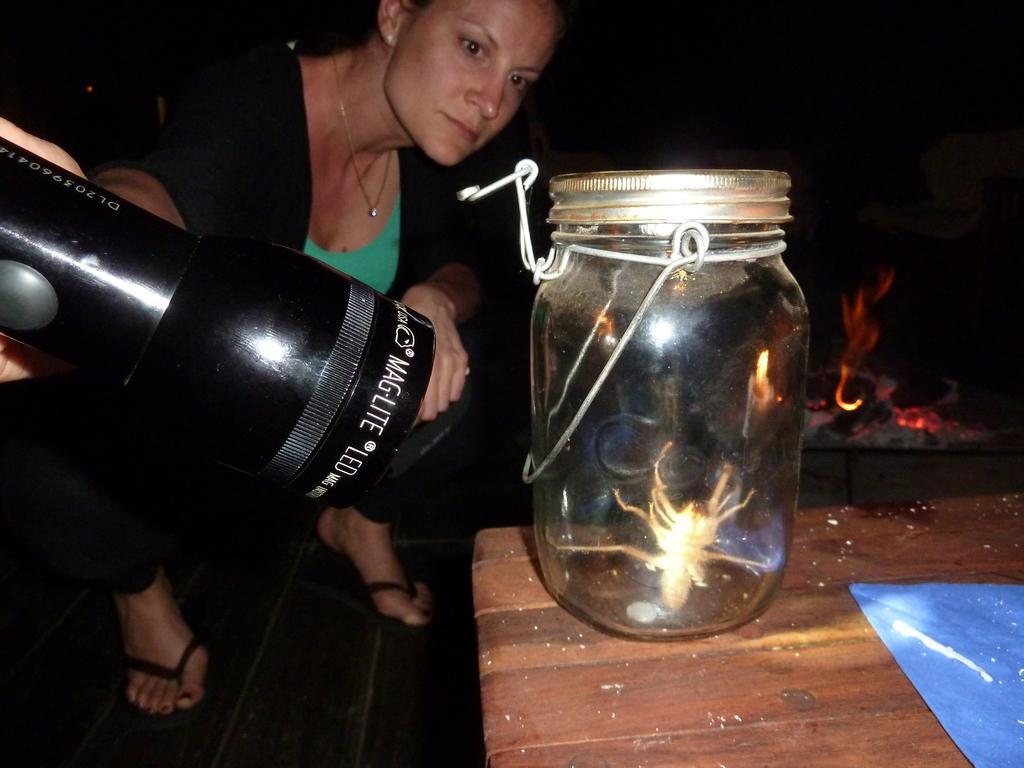Could you give a brief overview of what you see in this image? There is one woman sitting on the floor and holding a torch at the bottom of this image. There is a glass bottle is kept on a wooden surface as we can see at the bottom of this image and there is a fire in the background. 